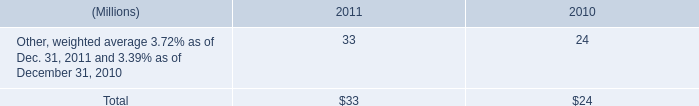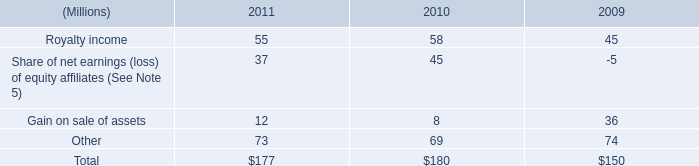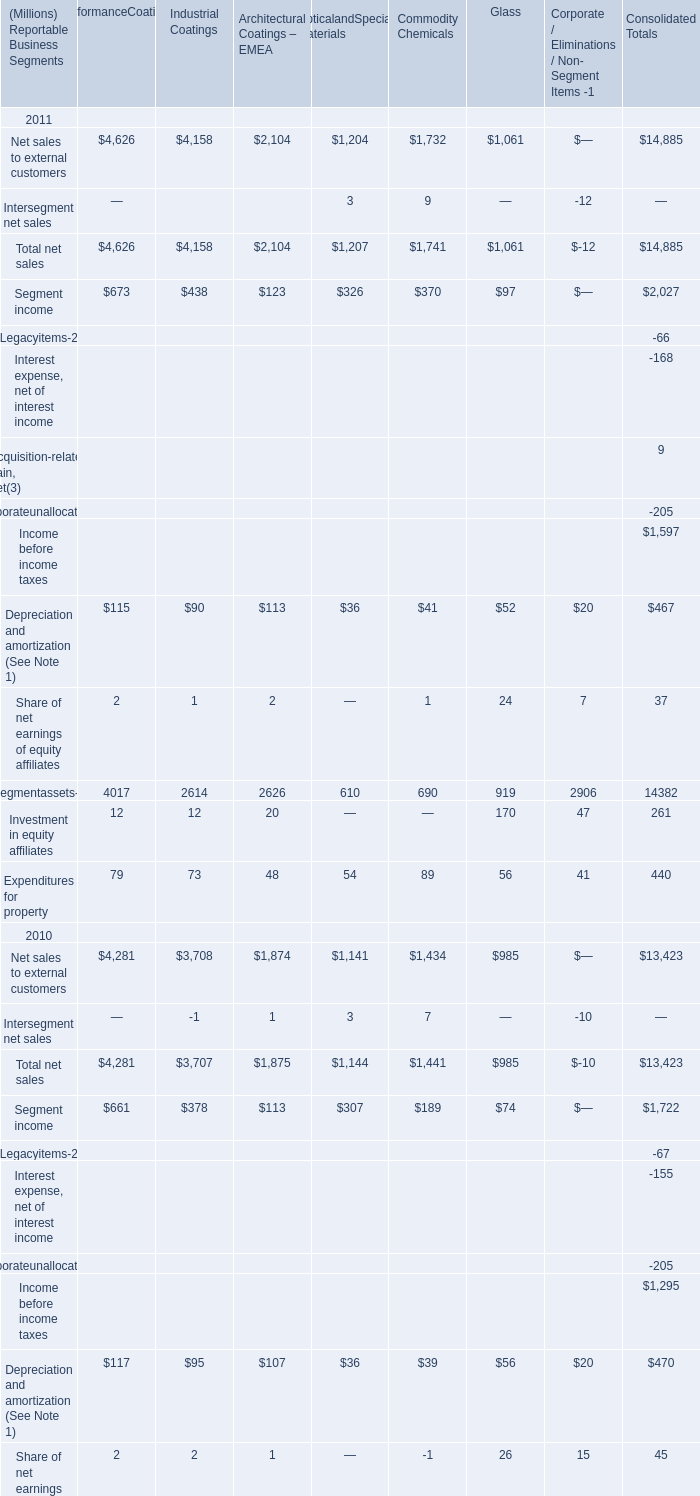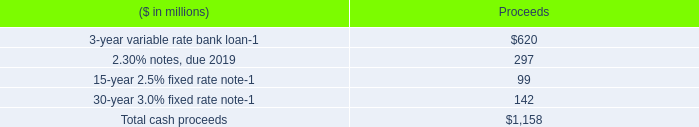Which year is Total net sales for Commodity Chemicals more? 
Answer: 2011. 